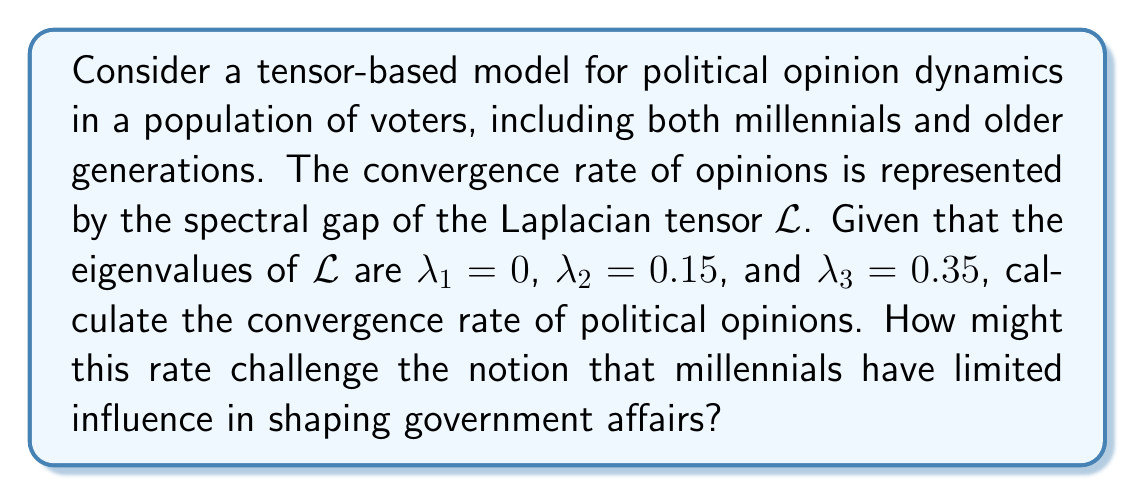Can you answer this question? To solve this problem, we'll follow these steps:

1) In tensor-based models of opinion dynamics, the convergence rate is determined by the spectral gap of the Laplacian tensor $\mathcal{L}$.

2) The spectral gap is defined as the difference between the two smallest non-zero eigenvalues of $\mathcal{L}$.

3) Given eigenvalues:
   $\lambda_1 = 0$
   $\lambda_2 = 0.15$
   $\lambda_3 = 0.35$

4) The smallest non-zero eigenvalue is $\lambda_2 = 0.15$.

5) The second smallest non-zero eigenvalue is $\lambda_3 = 0.35$.

6) The spectral gap is thus:
   $$\text{Spectral Gap} = \lambda_3 - \lambda_2 = 0.35 - 0.15 = 0.2$$

7) The convergence rate is directly proportional to the spectral gap. A larger spectral gap indicates faster convergence of opinions.

8) The calculated spectral gap of 0.2 suggests a relatively fast convergence rate of political opinions across all age groups, including millennials.

This rapid convergence rate challenges the notion that millennials have limited influence in shaping government affairs. It indicates that their opinions can quickly propagate and impact the overall political landscape, potentially leading to faster changes in political dynamics than traditionally expected.
Answer: 0.2 